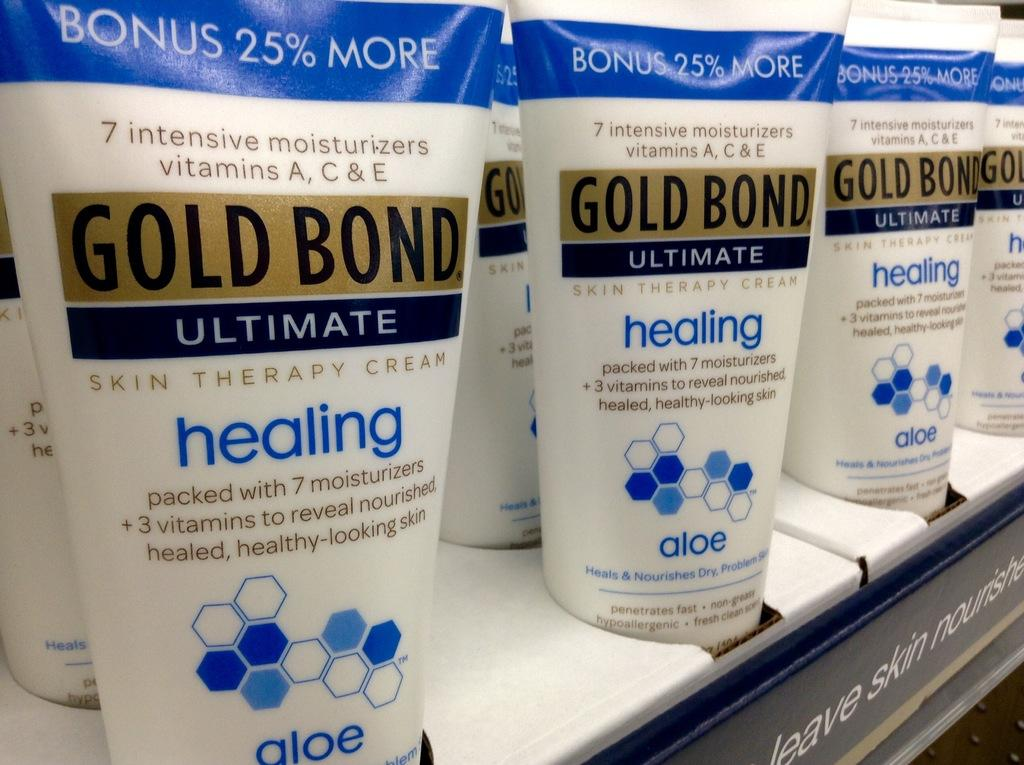Provide a one-sentence caption for the provided image. Tubes of Gold Bond ultimate healing aloe are standing next to each other. 